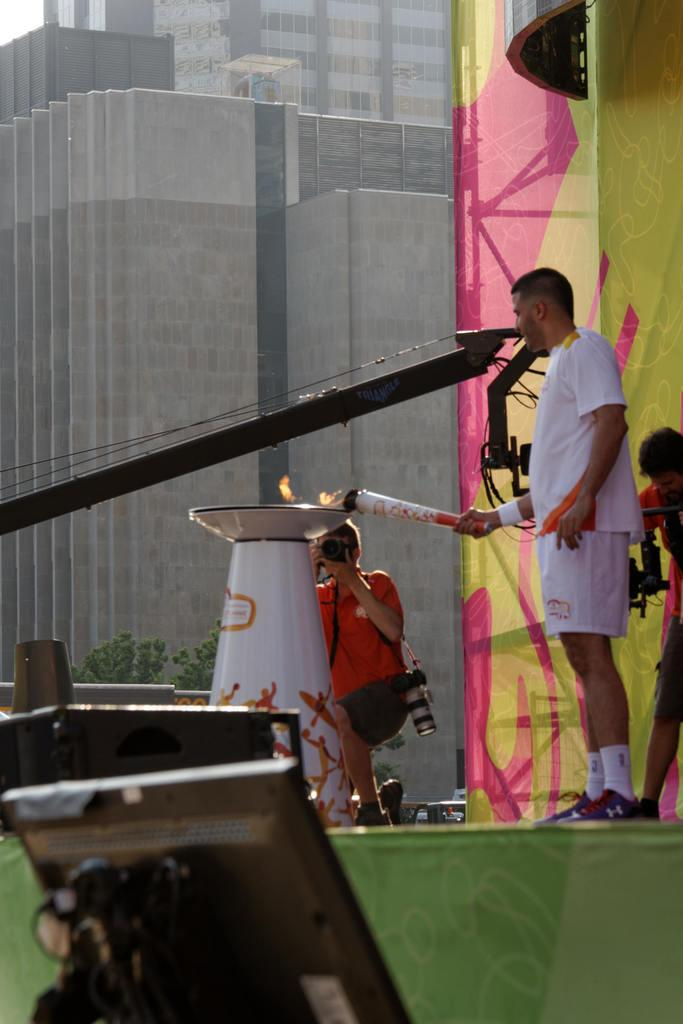What is the man in the image doing? The man is standing in the image and holding an object. What can be seen in the background of the image? There is a building in the image. Who else is present in the image? There is a person holding a camera in the image. What electronic device is visible in the image? There is a monitor in the image. Are there any cobwebs visible in the image? There is no mention of cobwebs in the provided facts, and therefore we cannot determine if any are present in the image. 